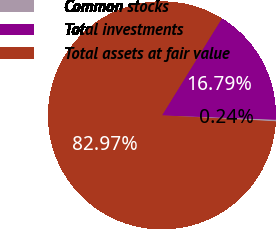Convert chart. <chart><loc_0><loc_0><loc_500><loc_500><pie_chart><fcel>Common stocks<fcel>Total investments<fcel>Total assets at fair value<nl><fcel>0.24%<fcel>16.79%<fcel>82.97%<nl></chart> 